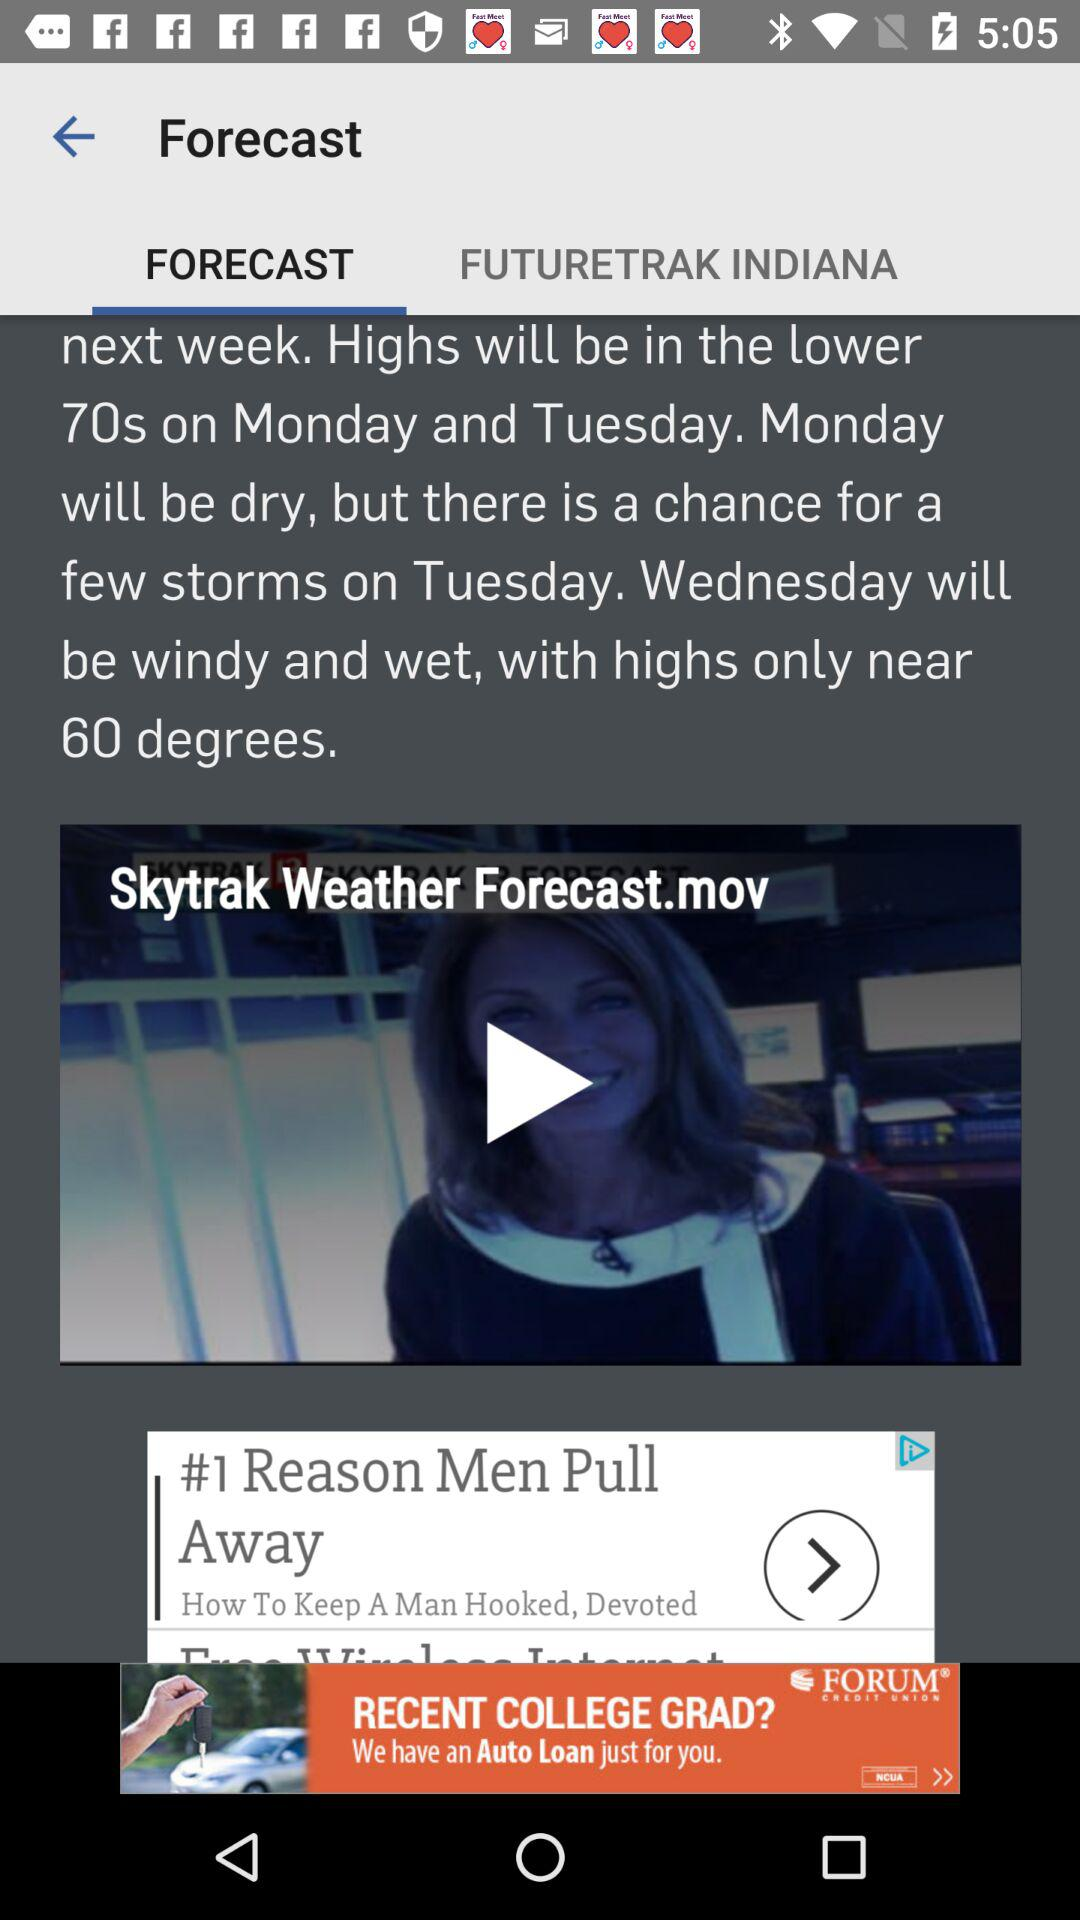How many days in the forecast are not Tuesday?
Answer the question using a single word or phrase. 2 